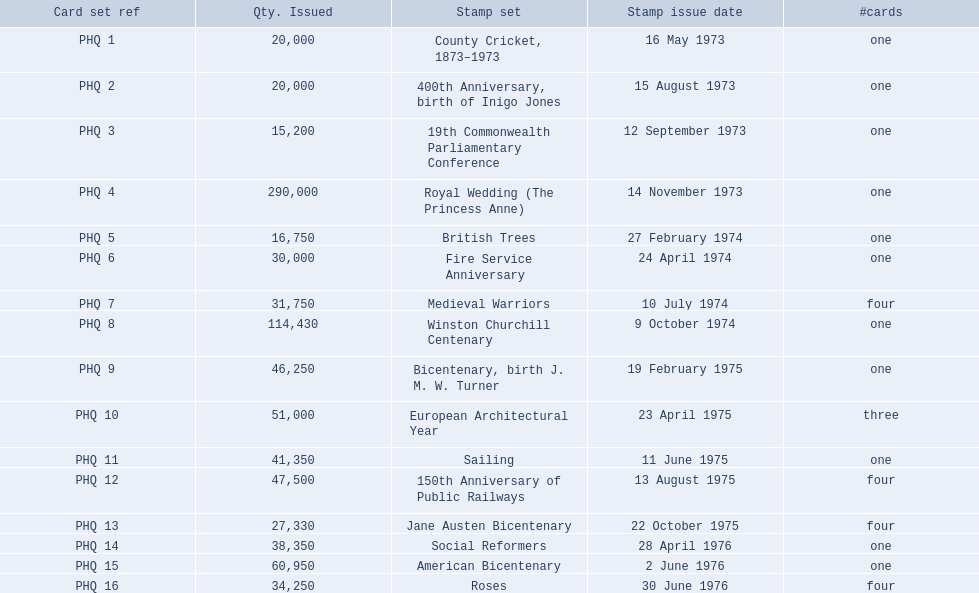Which stamp sets contained more than one card? Medieval Warriors, European Architectural Year, 150th Anniversary of Public Railways, Jane Austen Bicentenary, Roses. Of those stamp sets, which contains a unique number of cards? European Architectural Year. 